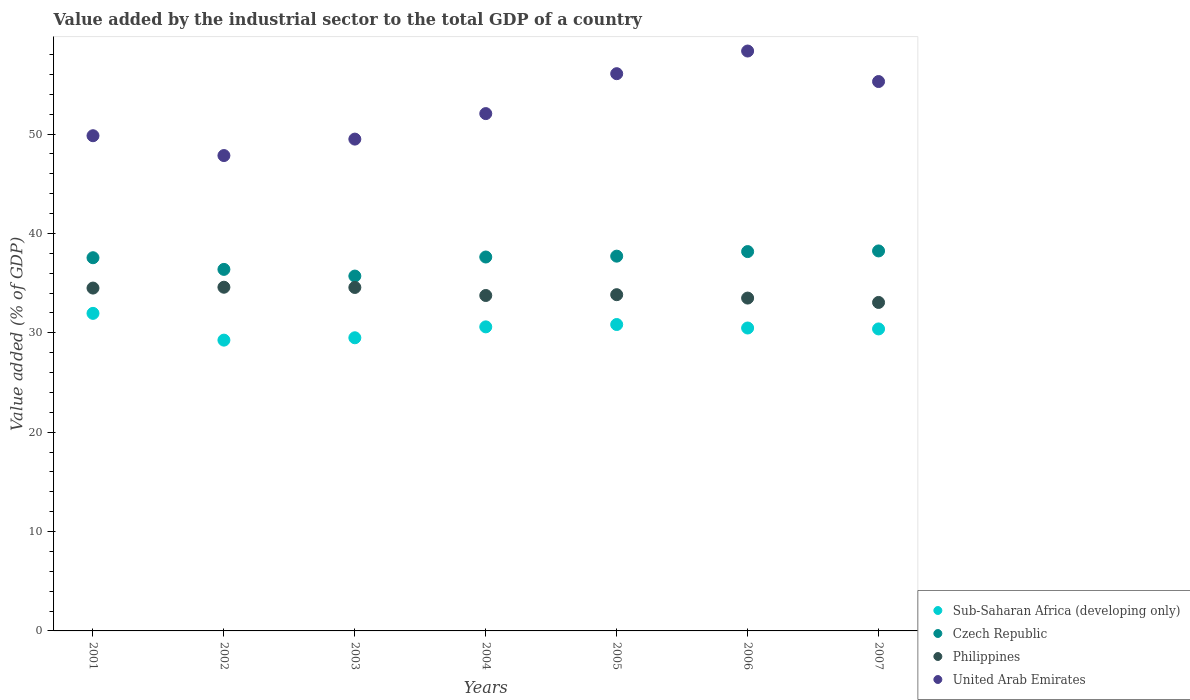How many different coloured dotlines are there?
Offer a very short reply. 4. Is the number of dotlines equal to the number of legend labels?
Offer a terse response. Yes. What is the value added by the industrial sector to the total GDP in Philippines in 2007?
Provide a short and direct response. 33.05. Across all years, what is the maximum value added by the industrial sector to the total GDP in Sub-Saharan Africa (developing only)?
Keep it short and to the point. 31.95. Across all years, what is the minimum value added by the industrial sector to the total GDP in United Arab Emirates?
Your answer should be compact. 47.83. In which year was the value added by the industrial sector to the total GDP in United Arab Emirates maximum?
Provide a short and direct response. 2006. In which year was the value added by the industrial sector to the total GDP in Sub-Saharan Africa (developing only) minimum?
Offer a very short reply. 2002. What is the total value added by the industrial sector to the total GDP in Sub-Saharan Africa (developing only) in the graph?
Make the answer very short. 213.01. What is the difference between the value added by the industrial sector to the total GDP in Sub-Saharan Africa (developing only) in 2002 and that in 2004?
Provide a short and direct response. -1.34. What is the difference between the value added by the industrial sector to the total GDP in Philippines in 2003 and the value added by the industrial sector to the total GDP in Czech Republic in 2001?
Offer a very short reply. -2.99. What is the average value added by the industrial sector to the total GDP in United Arab Emirates per year?
Offer a very short reply. 52.7. In the year 2001, what is the difference between the value added by the industrial sector to the total GDP in United Arab Emirates and value added by the industrial sector to the total GDP in Philippines?
Provide a short and direct response. 15.33. In how many years, is the value added by the industrial sector to the total GDP in United Arab Emirates greater than 50 %?
Your answer should be very brief. 4. What is the ratio of the value added by the industrial sector to the total GDP in United Arab Emirates in 2004 to that in 2005?
Give a very brief answer. 0.93. Is the difference between the value added by the industrial sector to the total GDP in United Arab Emirates in 2006 and 2007 greater than the difference between the value added by the industrial sector to the total GDP in Philippines in 2006 and 2007?
Provide a short and direct response. Yes. What is the difference between the highest and the second highest value added by the industrial sector to the total GDP in Sub-Saharan Africa (developing only)?
Your answer should be very brief. 1.12. What is the difference between the highest and the lowest value added by the industrial sector to the total GDP in Sub-Saharan Africa (developing only)?
Provide a succinct answer. 2.69. In how many years, is the value added by the industrial sector to the total GDP in United Arab Emirates greater than the average value added by the industrial sector to the total GDP in United Arab Emirates taken over all years?
Give a very brief answer. 3. Is the sum of the value added by the industrial sector to the total GDP in Sub-Saharan Africa (developing only) in 2001 and 2006 greater than the maximum value added by the industrial sector to the total GDP in Czech Republic across all years?
Provide a succinct answer. Yes. Is it the case that in every year, the sum of the value added by the industrial sector to the total GDP in Czech Republic and value added by the industrial sector to the total GDP in United Arab Emirates  is greater than the sum of value added by the industrial sector to the total GDP in Sub-Saharan Africa (developing only) and value added by the industrial sector to the total GDP in Philippines?
Provide a short and direct response. Yes. Is it the case that in every year, the sum of the value added by the industrial sector to the total GDP in United Arab Emirates and value added by the industrial sector to the total GDP in Philippines  is greater than the value added by the industrial sector to the total GDP in Czech Republic?
Your response must be concise. Yes. Is the value added by the industrial sector to the total GDP in Philippines strictly less than the value added by the industrial sector to the total GDP in Czech Republic over the years?
Your answer should be very brief. Yes. Where does the legend appear in the graph?
Provide a short and direct response. Bottom right. How are the legend labels stacked?
Make the answer very short. Vertical. What is the title of the graph?
Your response must be concise. Value added by the industrial sector to the total GDP of a country. Does "Guam" appear as one of the legend labels in the graph?
Your response must be concise. No. What is the label or title of the Y-axis?
Offer a terse response. Value added (% of GDP). What is the Value added (% of GDP) of Sub-Saharan Africa (developing only) in 2001?
Your answer should be compact. 31.95. What is the Value added (% of GDP) in Czech Republic in 2001?
Ensure brevity in your answer.  37.55. What is the Value added (% of GDP) in Philippines in 2001?
Provide a short and direct response. 34.5. What is the Value added (% of GDP) in United Arab Emirates in 2001?
Ensure brevity in your answer.  49.83. What is the Value added (% of GDP) of Sub-Saharan Africa (developing only) in 2002?
Provide a short and direct response. 29.26. What is the Value added (% of GDP) of Czech Republic in 2002?
Provide a succinct answer. 36.38. What is the Value added (% of GDP) of Philippines in 2002?
Ensure brevity in your answer.  34.58. What is the Value added (% of GDP) of United Arab Emirates in 2002?
Make the answer very short. 47.83. What is the Value added (% of GDP) of Sub-Saharan Africa (developing only) in 2003?
Provide a short and direct response. 29.5. What is the Value added (% of GDP) of Czech Republic in 2003?
Your answer should be very brief. 35.71. What is the Value added (% of GDP) in Philippines in 2003?
Offer a very short reply. 34.56. What is the Value added (% of GDP) of United Arab Emirates in 2003?
Your response must be concise. 49.49. What is the Value added (% of GDP) of Sub-Saharan Africa (developing only) in 2004?
Your answer should be compact. 30.6. What is the Value added (% of GDP) in Czech Republic in 2004?
Provide a succinct answer. 37.63. What is the Value added (% of GDP) in Philippines in 2004?
Provide a succinct answer. 33.75. What is the Value added (% of GDP) of United Arab Emirates in 2004?
Keep it short and to the point. 52.06. What is the Value added (% of GDP) of Sub-Saharan Africa (developing only) in 2005?
Offer a terse response. 30.83. What is the Value added (% of GDP) in Czech Republic in 2005?
Provide a short and direct response. 37.71. What is the Value added (% of GDP) in Philippines in 2005?
Make the answer very short. 33.83. What is the Value added (% of GDP) in United Arab Emirates in 2005?
Your answer should be very brief. 56.07. What is the Value added (% of GDP) of Sub-Saharan Africa (developing only) in 2006?
Offer a very short reply. 30.48. What is the Value added (% of GDP) in Czech Republic in 2006?
Offer a very short reply. 38.17. What is the Value added (% of GDP) of Philippines in 2006?
Your answer should be compact. 33.49. What is the Value added (% of GDP) of United Arab Emirates in 2006?
Your answer should be compact. 58.35. What is the Value added (% of GDP) in Sub-Saharan Africa (developing only) in 2007?
Offer a very short reply. 30.39. What is the Value added (% of GDP) of Czech Republic in 2007?
Offer a very short reply. 38.24. What is the Value added (% of GDP) in Philippines in 2007?
Your response must be concise. 33.05. What is the Value added (% of GDP) in United Arab Emirates in 2007?
Provide a succinct answer. 55.28. Across all years, what is the maximum Value added (% of GDP) of Sub-Saharan Africa (developing only)?
Offer a terse response. 31.95. Across all years, what is the maximum Value added (% of GDP) of Czech Republic?
Offer a very short reply. 38.24. Across all years, what is the maximum Value added (% of GDP) in Philippines?
Offer a very short reply. 34.58. Across all years, what is the maximum Value added (% of GDP) of United Arab Emirates?
Keep it short and to the point. 58.35. Across all years, what is the minimum Value added (% of GDP) in Sub-Saharan Africa (developing only)?
Provide a short and direct response. 29.26. Across all years, what is the minimum Value added (% of GDP) of Czech Republic?
Give a very brief answer. 35.71. Across all years, what is the minimum Value added (% of GDP) of Philippines?
Give a very brief answer. 33.05. Across all years, what is the minimum Value added (% of GDP) of United Arab Emirates?
Offer a very short reply. 47.83. What is the total Value added (% of GDP) in Sub-Saharan Africa (developing only) in the graph?
Your answer should be compact. 213.01. What is the total Value added (% of GDP) in Czech Republic in the graph?
Ensure brevity in your answer.  261.38. What is the total Value added (% of GDP) in Philippines in the graph?
Provide a succinct answer. 237.78. What is the total Value added (% of GDP) of United Arab Emirates in the graph?
Your answer should be very brief. 368.91. What is the difference between the Value added (% of GDP) in Sub-Saharan Africa (developing only) in 2001 and that in 2002?
Ensure brevity in your answer.  2.69. What is the difference between the Value added (% of GDP) in Czech Republic in 2001 and that in 2002?
Provide a succinct answer. 1.17. What is the difference between the Value added (% of GDP) of Philippines in 2001 and that in 2002?
Give a very brief answer. -0.08. What is the difference between the Value added (% of GDP) of United Arab Emirates in 2001 and that in 2002?
Give a very brief answer. 2. What is the difference between the Value added (% of GDP) in Sub-Saharan Africa (developing only) in 2001 and that in 2003?
Keep it short and to the point. 2.46. What is the difference between the Value added (% of GDP) in Czech Republic in 2001 and that in 2003?
Your answer should be very brief. 1.85. What is the difference between the Value added (% of GDP) in Philippines in 2001 and that in 2003?
Give a very brief answer. -0.06. What is the difference between the Value added (% of GDP) of United Arab Emirates in 2001 and that in 2003?
Make the answer very short. 0.34. What is the difference between the Value added (% of GDP) of Sub-Saharan Africa (developing only) in 2001 and that in 2004?
Keep it short and to the point. 1.36. What is the difference between the Value added (% of GDP) in Czech Republic in 2001 and that in 2004?
Offer a terse response. -0.07. What is the difference between the Value added (% of GDP) in Philippines in 2001 and that in 2004?
Offer a very short reply. 0.75. What is the difference between the Value added (% of GDP) of United Arab Emirates in 2001 and that in 2004?
Give a very brief answer. -2.23. What is the difference between the Value added (% of GDP) of Sub-Saharan Africa (developing only) in 2001 and that in 2005?
Provide a succinct answer. 1.12. What is the difference between the Value added (% of GDP) in Czech Republic in 2001 and that in 2005?
Offer a very short reply. -0.16. What is the difference between the Value added (% of GDP) of Philippines in 2001 and that in 2005?
Ensure brevity in your answer.  0.67. What is the difference between the Value added (% of GDP) in United Arab Emirates in 2001 and that in 2005?
Give a very brief answer. -6.24. What is the difference between the Value added (% of GDP) in Sub-Saharan Africa (developing only) in 2001 and that in 2006?
Ensure brevity in your answer.  1.47. What is the difference between the Value added (% of GDP) in Czech Republic in 2001 and that in 2006?
Your answer should be very brief. -0.62. What is the difference between the Value added (% of GDP) of Philippines in 2001 and that in 2006?
Provide a succinct answer. 1.01. What is the difference between the Value added (% of GDP) in United Arab Emirates in 2001 and that in 2006?
Make the answer very short. -8.52. What is the difference between the Value added (% of GDP) in Sub-Saharan Africa (developing only) in 2001 and that in 2007?
Your answer should be very brief. 1.57. What is the difference between the Value added (% of GDP) of Czech Republic in 2001 and that in 2007?
Give a very brief answer. -0.68. What is the difference between the Value added (% of GDP) of Philippines in 2001 and that in 2007?
Your answer should be very brief. 1.45. What is the difference between the Value added (% of GDP) of United Arab Emirates in 2001 and that in 2007?
Offer a terse response. -5.45. What is the difference between the Value added (% of GDP) in Sub-Saharan Africa (developing only) in 2002 and that in 2003?
Your answer should be very brief. -0.24. What is the difference between the Value added (% of GDP) of Czech Republic in 2002 and that in 2003?
Offer a terse response. 0.67. What is the difference between the Value added (% of GDP) in Philippines in 2002 and that in 2003?
Keep it short and to the point. 0.02. What is the difference between the Value added (% of GDP) of United Arab Emirates in 2002 and that in 2003?
Your answer should be very brief. -1.66. What is the difference between the Value added (% of GDP) of Sub-Saharan Africa (developing only) in 2002 and that in 2004?
Your response must be concise. -1.34. What is the difference between the Value added (% of GDP) of Czech Republic in 2002 and that in 2004?
Offer a terse response. -1.25. What is the difference between the Value added (% of GDP) of Philippines in 2002 and that in 2004?
Your answer should be very brief. 0.83. What is the difference between the Value added (% of GDP) of United Arab Emirates in 2002 and that in 2004?
Your response must be concise. -4.22. What is the difference between the Value added (% of GDP) in Sub-Saharan Africa (developing only) in 2002 and that in 2005?
Your answer should be compact. -1.57. What is the difference between the Value added (% of GDP) in Czech Republic in 2002 and that in 2005?
Ensure brevity in your answer.  -1.33. What is the difference between the Value added (% of GDP) in Philippines in 2002 and that in 2005?
Ensure brevity in your answer.  0.75. What is the difference between the Value added (% of GDP) of United Arab Emirates in 2002 and that in 2005?
Ensure brevity in your answer.  -8.24. What is the difference between the Value added (% of GDP) of Sub-Saharan Africa (developing only) in 2002 and that in 2006?
Offer a terse response. -1.22. What is the difference between the Value added (% of GDP) of Czech Republic in 2002 and that in 2006?
Offer a very short reply. -1.79. What is the difference between the Value added (% of GDP) of Philippines in 2002 and that in 2006?
Provide a succinct answer. 1.09. What is the difference between the Value added (% of GDP) in United Arab Emirates in 2002 and that in 2006?
Provide a succinct answer. -10.52. What is the difference between the Value added (% of GDP) of Sub-Saharan Africa (developing only) in 2002 and that in 2007?
Offer a terse response. -1.13. What is the difference between the Value added (% of GDP) of Czech Republic in 2002 and that in 2007?
Offer a very short reply. -1.86. What is the difference between the Value added (% of GDP) of Philippines in 2002 and that in 2007?
Your answer should be compact. 1.53. What is the difference between the Value added (% of GDP) in United Arab Emirates in 2002 and that in 2007?
Give a very brief answer. -7.45. What is the difference between the Value added (% of GDP) in Sub-Saharan Africa (developing only) in 2003 and that in 2004?
Keep it short and to the point. -1.1. What is the difference between the Value added (% of GDP) of Czech Republic in 2003 and that in 2004?
Ensure brevity in your answer.  -1.92. What is the difference between the Value added (% of GDP) in Philippines in 2003 and that in 2004?
Keep it short and to the point. 0.81. What is the difference between the Value added (% of GDP) of United Arab Emirates in 2003 and that in 2004?
Provide a succinct answer. -2.57. What is the difference between the Value added (% of GDP) of Sub-Saharan Africa (developing only) in 2003 and that in 2005?
Provide a short and direct response. -1.33. What is the difference between the Value added (% of GDP) of Czech Republic in 2003 and that in 2005?
Keep it short and to the point. -2. What is the difference between the Value added (% of GDP) of Philippines in 2003 and that in 2005?
Provide a succinct answer. 0.73. What is the difference between the Value added (% of GDP) in United Arab Emirates in 2003 and that in 2005?
Offer a very short reply. -6.58. What is the difference between the Value added (% of GDP) in Sub-Saharan Africa (developing only) in 2003 and that in 2006?
Make the answer very short. -0.98. What is the difference between the Value added (% of GDP) of Czech Republic in 2003 and that in 2006?
Your answer should be compact. -2.46. What is the difference between the Value added (% of GDP) of Philippines in 2003 and that in 2006?
Offer a terse response. 1.07. What is the difference between the Value added (% of GDP) of United Arab Emirates in 2003 and that in 2006?
Keep it short and to the point. -8.86. What is the difference between the Value added (% of GDP) of Sub-Saharan Africa (developing only) in 2003 and that in 2007?
Offer a very short reply. -0.89. What is the difference between the Value added (% of GDP) in Czech Republic in 2003 and that in 2007?
Your response must be concise. -2.53. What is the difference between the Value added (% of GDP) in Philippines in 2003 and that in 2007?
Make the answer very short. 1.51. What is the difference between the Value added (% of GDP) in United Arab Emirates in 2003 and that in 2007?
Give a very brief answer. -5.79. What is the difference between the Value added (% of GDP) in Sub-Saharan Africa (developing only) in 2004 and that in 2005?
Your answer should be very brief. -0.24. What is the difference between the Value added (% of GDP) of Czech Republic in 2004 and that in 2005?
Offer a terse response. -0.09. What is the difference between the Value added (% of GDP) in Philippines in 2004 and that in 2005?
Keep it short and to the point. -0.08. What is the difference between the Value added (% of GDP) in United Arab Emirates in 2004 and that in 2005?
Ensure brevity in your answer.  -4.02. What is the difference between the Value added (% of GDP) of Sub-Saharan Africa (developing only) in 2004 and that in 2006?
Ensure brevity in your answer.  0.11. What is the difference between the Value added (% of GDP) of Czech Republic in 2004 and that in 2006?
Your answer should be very brief. -0.55. What is the difference between the Value added (% of GDP) in Philippines in 2004 and that in 2006?
Your answer should be very brief. 0.26. What is the difference between the Value added (% of GDP) in United Arab Emirates in 2004 and that in 2006?
Your answer should be compact. -6.3. What is the difference between the Value added (% of GDP) of Sub-Saharan Africa (developing only) in 2004 and that in 2007?
Provide a succinct answer. 0.21. What is the difference between the Value added (% of GDP) of Czech Republic in 2004 and that in 2007?
Keep it short and to the point. -0.61. What is the difference between the Value added (% of GDP) in Philippines in 2004 and that in 2007?
Provide a succinct answer. 0.7. What is the difference between the Value added (% of GDP) of United Arab Emirates in 2004 and that in 2007?
Offer a terse response. -3.23. What is the difference between the Value added (% of GDP) in Sub-Saharan Africa (developing only) in 2005 and that in 2006?
Offer a terse response. 0.35. What is the difference between the Value added (% of GDP) of Czech Republic in 2005 and that in 2006?
Provide a succinct answer. -0.46. What is the difference between the Value added (% of GDP) in Philippines in 2005 and that in 2006?
Keep it short and to the point. 0.34. What is the difference between the Value added (% of GDP) of United Arab Emirates in 2005 and that in 2006?
Provide a succinct answer. -2.28. What is the difference between the Value added (% of GDP) of Sub-Saharan Africa (developing only) in 2005 and that in 2007?
Provide a short and direct response. 0.44. What is the difference between the Value added (% of GDP) in Czech Republic in 2005 and that in 2007?
Your response must be concise. -0.53. What is the difference between the Value added (% of GDP) of Philippines in 2005 and that in 2007?
Your answer should be compact. 0.78. What is the difference between the Value added (% of GDP) in United Arab Emirates in 2005 and that in 2007?
Provide a short and direct response. 0.79. What is the difference between the Value added (% of GDP) in Sub-Saharan Africa (developing only) in 2006 and that in 2007?
Your answer should be very brief. 0.09. What is the difference between the Value added (% of GDP) of Czech Republic in 2006 and that in 2007?
Keep it short and to the point. -0.07. What is the difference between the Value added (% of GDP) in Philippines in 2006 and that in 2007?
Provide a succinct answer. 0.44. What is the difference between the Value added (% of GDP) in United Arab Emirates in 2006 and that in 2007?
Give a very brief answer. 3.07. What is the difference between the Value added (% of GDP) in Sub-Saharan Africa (developing only) in 2001 and the Value added (% of GDP) in Czech Republic in 2002?
Offer a very short reply. -4.43. What is the difference between the Value added (% of GDP) in Sub-Saharan Africa (developing only) in 2001 and the Value added (% of GDP) in Philippines in 2002?
Provide a short and direct response. -2.63. What is the difference between the Value added (% of GDP) of Sub-Saharan Africa (developing only) in 2001 and the Value added (% of GDP) of United Arab Emirates in 2002?
Your answer should be very brief. -15.88. What is the difference between the Value added (% of GDP) of Czech Republic in 2001 and the Value added (% of GDP) of Philippines in 2002?
Keep it short and to the point. 2.97. What is the difference between the Value added (% of GDP) in Czech Republic in 2001 and the Value added (% of GDP) in United Arab Emirates in 2002?
Offer a terse response. -10.28. What is the difference between the Value added (% of GDP) of Philippines in 2001 and the Value added (% of GDP) of United Arab Emirates in 2002?
Your answer should be very brief. -13.33. What is the difference between the Value added (% of GDP) of Sub-Saharan Africa (developing only) in 2001 and the Value added (% of GDP) of Czech Republic in 2003?
Give a very brief answer. -3.75. What is the difference between the Value added (% of GDP) in Sub-Saharan Africa (developing only) in 2001 and the Value added (% of GDP) in Philippines in 2003?
Your response must be concise. -2.61. What is the difference between the Value added (% of GDP) in Sub-Saharan Africa (developing only) in 2001 and the Value added (% of GDP) in United Arab Emirates in 2003?
Keep it short and to the point. -17.53. What is the difference between the Value added (% of GDP) of Czech Republic in 2001 and the Value added (% of GDP) of Philippines in 2003?
Keep it short and to the point. 2.99. What is the difference between the Value added (% of GDP) in Czech Republic in 2001 and the Value added (% of GDP) in United Arab Emirates in 2003?
Provide a succinct answer. -11.94. What is the difference between the Value added (% of GDP) in Philippines in 2001 and the Value added (% of GDP) in United Arab Emirates in 2003?
Keep it short and to the point. -14.99. What is the difference between the Value added (% of GDP) of Sub-Saharan Africa (developing only) in 2001 and the Value added (% of GDP) of Czech Republic in 2004?
Provide a short and direct response. -5.67. What is the difference between the Value added (% of GDP) in Sub-Saharan Africa (developing only) in 2001 and the Value added (% of GDP) in Philippines in 2004?
Provide a short and direct response. -1.8. What is the difference between the Value added (% of GDP) of Sub-Saharan Africa (developing only) in 2001 and the Value added (% of GDP) of United Arab Emirates in 2004?
Offer a very short reply. -20.1. What is the difference between the Value added (% of GDP) in Czech Republic in 2001 and the Value added (% of GDP) in Philippines in 2004?
Your answer should be very brief. 3.8. What is the difference between the Value added (% of GDP) of Czech Republic in 2001 and the Value added (% of GDP) of United Arab Emirates in 2004?
Offer a terse response. -14.5. What is the difference between the Value added (% of GDP) in Philippines in 2001 and the Value added (% of GDP) in United Arab Emirates in 2004?
Ensure brevity in your answer.  -17.56. What is the difference between the Value added (% of GDP) of Sub-Saharan Africa (developing only) in 2001 and the Value added (% of GDP) of Czech Republic in 2005?
Your answer should be compact. -5.76. What is the difference between the Value added (% of GDP) of Sub-Saharan Africa (developing only) in 2001 and the Value added (% of GDP) of Philippines in 2005?
Provide a succinct answer. -1.88. What is the difference between the Value added (% of GDP) of Sub-Saharan Africa (developing only) in 2001 and the Value added (% of GDP) of United Arab Emirates in 2005?
Offer a terse response. -24.12. What is the difference between the Value added (% of GDP) in Czech Republic in 2001 and the Value added (% of GDP) in Philippines in 2005?
Give a very brief answer. 3.72. What is the difference between the Value added (% of GDP) in Czech Republic in 2001 and the Value added (% of GDP) in United Arab Emirates in 2005?
Give a very brief answer. -18.52. What is the difference between the Value added (% of GDP) of Philippines in 2001 and the Value added (% of GDP) of United Arab Emirates in 2005?
Keep it short and to the point. -21.57. What is the difference between the Value added (% of GDP) in Sub-Saharan Africa (developing only) in 2001 and the Value added (% of GDP) in Czech Republic in 2006?
Your response must be concise. -6.22. What is the difference between the Value added (% of GDP) of Sub-Saharan Africa (developing only) in 2001 and the Value added (% of GDP) of Philippines in 2006?
Provide a succinct answer. -1.54. What is the difference between the Value added (% of GDP) of Sub-Saharan Africa (developing only) in 2001 and the Value added (% of GDP) of United Arab Emirates in 2006?
Offer a terse response. -26.4. What is the difference between the Value added (% of GDP) in Czech Republic in 2001 and the Value added (% of GDP) in Philippines in 2006?
Ensure brevity in your answer.  4.06. What is the difference between the Value added (% of GDP) of Czech Republic in 2001 and the Value added (% of GDP) of United Arab Emirates in 2006?
Provide a short and direct response. -20.8. What is the difference between the Value added (% of GDP) of Philippines in 2001 and the Value added (% of GDP) of United Arab Emirates in 2006?
Keep it short and to the point. -23.85. What is the difference between the Value added (% of GDP) in Sub-Saharan Africa (developing only) in 2001 and the Value added (% of GDP) in Czech Republic in 2007?
Your answer should be compact. -6.28. What is the difference between the Value added (% of GDP) in Sub-Saharan Africa (developing only) in 2001 and the Value added (% of GDP) in Philippines in 2007?
Your response must be concise. -1.1. What is the difference between the Value added (% of GDP) of Sub-Saharan Africa (developing only) in 2001 and the Value added (% of GDP) of United Arab Emirates in 2007?
Provide a succinct answer. -23.33. What is the difference between the Value added (% of GDP) of Czech Republic in 2001 and the Value added (% of GDP) of Philippines in 2007?
Keep it short and to the point. 4.5. What is the difference between the Value added (% of GDP) in Czech Republic in 2001 and the Value added (% of GDP) in United Arab Emirates in 2007?
Your response must be concise. -17.73. What is the difference between the Value added (% of GDP) in Philippines in 2001 and the Value added (% of GDP) in United Arab Emirates in 2007?
Make the answer very short. -20.78. What is the difference between the Value added (% of GDP) in Sub-Saharan Africa (developing only) in 2002 and the Value added (% of GDP) in Czech Republic in 2003?
Your answer should be compact. -6.45. What is the difference between the Value added (% of GDP) of Sub-Saharan Africa (developing only) in 2002 and the Value added (% of GDP) of Philippines in 2003?
Make the answer very short. -5.3. What is the difference between the Value added (% of GDP) in Sub-Saharan Africa (developing only) in 2002 and the Value added (% of GDP) in United Arab Emirates in 2003?
Your answer should be compact. -20.23. What is the difference between the Value added (% of GDP) of Czech Republic in 2002 and the Value added (% of GDP) of Philippines in 2003?
Offer a terse response. 1.82. What is the difference between the Value added (% of GDP) of Czech Republic in 2002 and the Value added (% of GDP) of United Arab Emirates in 2003?
Ensure brevity in your answer.  -13.11. What is the difference between the Value added (% of GDP) in Philippines in 2002 and the Value added (% of GDP) in United Arab Emirates in 2003?
Ensure brevity in your answer.  -14.91. What is the difference between the Value added (% of GDP) of Sub-Saharan Africa (developing only) in 2002 and the Value added (% of GDP) of Czech Republic in 2004?
Your answer should be very brief. -8.36. What is the difference between the Value added (% of GDP) of Sub-Saharan Africa (developing only) in 2002 and the Value added (% of GDP) of Philippines in 2004?
Provide a short and direct response. -4.49. What is the difference between the Value added (% of GDP) in Sub-Saharan Africa (developing only) in 2002 and the Value added (% of GDP) in United Arab Emirates in 2004?
Your answer should be compact. -22.8. What is the difference between the Value added (% of GDP) of Czech Republic in 2002 and the Value added (% of GDP) of Philippines in 2004?
Your answer should be compact. 2.63. What is the difference between the Value added (% of GDP) in Czech Republic in 2002 and the Value added (% of GDP) in United Arab Emirates in 2004?
Provide a short and direct response. -15.68. What is the difference between the Value added (% of GDP) of Philippines in 2002 and the Value added (% of GDP) of United Arab Emirates in 2004?
Offer a terse response. -17.47. What is the difference between the Value added (% of GDP) in Sub-Saharan Africa (developing only) in 2002 and the Value added (% of GDP) in Czech Republic in 2005?
Your answer should be compact. -8.45. What is the difference between the Value added (% of GDP) of Sub-Saharan Africa (developing only) in 2002 and the Value added (% of GDP) of Philippines in 2005?
Provide a succinct answer. -4.57. What is the difference between the Value added (% of GDP) of Sub-Saharan Africa (developing only) in 2002 and the Value added (% of GDP) of United Arab Emirates in 2005?
Provide a succinct answer. -26.81. What is the difference between the Value added (% of GDP) of Czech Republic in 2002 and the Value added (% of GDP) of Philippines in 2005?
Your response must be concise. 2.55. What is the difference between the Value added (% of GDP) of Czech Republic in 2002 and the Value added (% of GDP) of United Arab Emirates in 2005?
Give a very brief answer. -19.69. What is the difference between the Value added (% of GDP) of Philippines in 2002 and the Value added (% of GDP) of United Arab Emirates in 2005?
Make the answer very short. -21.49. What is the difference between the Value added (% of GDP) in Sub-Saharan Africa (developing only) in 2002 and the Value added (% of GDP) in Czech Republic in 2006?
Make the answer very short. -8.91. What is the difference between the Value added (% of GDP) of Sub-Saharan Africa (developing only) in 2002 and the Value added (% of GDP) of Philippines in 2006?
Keep it short and to the point. -4.23. What is the difference between the Value added (% of GDP) in Sub-Saharan Africa (developing only) in 2002 and the Value added (% of GDP) in United Arab Emirates in 2006?
Your answer should be very brief. -29.09. What is the difference between the Value added (% of GDP) in Czech Republic in 2002 and the Value added (% of GDP) in Philippines in 2006?
Ensure brevity in your answer.  2.89. What is the difference between the Value added (% of GDP) in Czech Republic in 2002 and the Value added (% of GDP) in United Arab Emirates in 2006?
Your answer should be compact. -21.97. What is the difference between the Value added (% of GDP) in Philippines in 2002 and the Value added (% of GDP) in United Arab Emirates in 2006?
Offer a very short reply. -23.77. What is the difference between the Value added (% of GDP) in Sub-Saharan Africa (developing only) in 2002 and the Value added (% of GDP) in Czech Republic in 2007?
Provide a succinct answer. -8.98. What is the difference between the Value added (% of GDP) in Sub-Saharan Africa (developing only) in 2002 and the Value added (% of GDP) in Philippines in 2007?
Your answer should be very brief. -3.79. What is the difference between the Value added (% of GDP) in Sub-Saharan Africa (developing only) in 2002 and the Value added (% of GDP) in United Arab Emirates in 2007?
Make the answer very short. -26.02. What is the difference between the Value added (% of GDP) in Czech Republic in 2002 and the Value added (% of GDP) in Philippines in 2007?
Your answer should be compact. 3.33. What is the difference between the Value added (% of GDP) of Czech Republic in 2002 and the Value added (% of GDP) of United Arab Emirates in 2007?
Offer a very short reply. -18.9. What is the difference between the Value added (% of GDP) of Philippines in 2002 and the Value added (% of GDP) of United Arab Emirates in 2007?
Your answer should be very brief. -20.7. What is the difference between the Value added (% of GDP) in Sub-Saharan Africa (developing only) in 2003 and the Value added (% of GDP) in Czech Republic in 2004?
Make the answer very short. -8.13. What is the difference between the Value added (% of GDP) in Sub-Saharan Africa (developing only) in 2003 and the Value added (% of GDP) in Philippines in 2004?
Ensure brevity in your answer.  -4.25. What is the difference between the Value added (% of GDP) in Sub-Saharan Africa (developing only) in 2003 and the Value added (% of GDP) in United Arab Emirates in 2004?
Offer a terse response. -22.56. What is the difference between the Value added (% of GDP) of Czech Republic in 2003 and the Value added (% of GDP) of Philippines in 2004?
Ensure brevity in your answer.  1.95. What is the difference between the Value added (% of GDP) in Czech Republic in 2003 and the Value added (% of GDP) in United Arab Emirates in 2004?
Offer a very short reply. -16.35. What is the difference between the Value added (% of GDP) in Philippines in 2003 and the Value added (% of GDP) in United Arab Emirates in 2004?
Give a very brief answer. -17.49. What is the difference between the Value added (% of GDP) in Sub-Saharan Africa (developing only) in 2003 and the Value added (% of GDP) in Czech Republic in 2005?
Your answer should be compact. -8.21. What is the difference between the Value added (% of GDP) of Sub-Saharan Africa (developing only) in 2003 and the Value added (% of GDP) of Philippines in 2005?
Make the answer very short. -4.34. What is the difference between the Value added (% of GDP) in Sub-Saharan Africa (developing only) in 2003 and the Value added (% of GDP) in United Arab Emirates in 2005?
Offer a very short reply. -26.57. What is the difference between the Value added (% of GDP) of Czech Republic in 2003 and the Value added (% of GDP) of Philippines in 2005?
Provide a short and direct response. 1.87. What is the difference between the Value added (% of GDP) of Czech Republic in 2003 and the Value added (% of GDP) of United Arab Emirates in 2005?
Your response must be concise. -20.36. What is the difference between the Value added (% of GDP) of Philippines in 2003 and the Value added (% of GDP) of United Arab Emirates in 2005?
Your answer should be very brief. -21.51. What is the difference between the Value added (% of GDP) in Sub-Saharan Africa (developing only) in 2003 and the Value added (% of GDP) in Czech Republic in 2006?
Ensure brevity in your answer.  -8.67. What is the difference between the Value added (% of GDP) of Sub-Saharan Africa (developing only) in 2003 and the Value added (% of GDP) of Philippines in 2006?
Provide a succinct answer. -3.99. What is the difference between the Value added (% of GDP) in Sub-Saharan Africa (developing only) in 2003 and the Value added (% of GDP) in United Arab Emirates in 2006?
Provide a succinct answer. -28.85. What is the difference between the Value added (% of GDP) in Czech Republic in 2003 and the Value added (% of GDP) in Philippines in 2006?
Keep it short and to the point. 2.21. What is the difference between the Value added (% of GDP) of Czech Republic in 2003 and the Value added (% of GDP) of United Arab Emirates in 2006?
Give a very brief answer. -22.64. What is the difference between the Value added (% of GDP) in Philippines in 2003 and the Value added (% of GDP) in United Arab Emirates in 2006?
Your answer should be very brief. -23.79. What is the difference between the Value added (% of GDP) in Sub-Saharan Africa (developing only) in 2003 and the Value added (% of GDP) in Czech Republic in 2007?
Ensure brevity in your answer.  -8.74. What is the difference between the Value added (% of GDP) in Sub-Saharan Africa (developing only) in 2003 and the Value added (% of GDP) in Philippines in 2007?
Give a very brief answer. -3.55. What is the difference between the Value added (% of GDP) of Sub-Saharan Africa (developing only) in 2003 and the Value added (% of GDP) of United Arab Emirates in 2007?
Keep it short and to the point. -25.78. What is the difference between the Value added (% of GDP) in Czech Republic in 2003 and the Value added (% of GDP) in Philippines in 2007?
Offer a very short reply. 2.65. What is the difference between the Value added (% of GDP) of Czech Republic in 2003 and the Value added (% of GDP) of United Arab Emirates in 2007?
Make the answer very short. -19.57. What is the difference between the Value added (% of GDP) in Philippines in 2003 and the Value added (% of GDP) in United Arab Emirates in 2007?
Give a very brief answer. -20.72. What is the difference between the Value added (% of GDP) of Sub-Saharan Africa (developing only) in 2004 and the Value added (% of GDP) of Czech Republic in 2005?
Your answer should be very brief. -7.12. What is the difference between the Value added (% of GDP) of Sub-Saharan Africa (developing only) in 2004 and the Value added (% of GDP) of Philippines in 2005?
Keep it short and to the point. -3.24. What is the difference between the Value added (% of GDP) of Sub-Saharan Africa (developing only) in 2004 and the Value added (% of GDP) of United Arab Emirates in 2005?
Provide a succinct answer. -25.48. What is the difference between the Value added (% of GDP) of Czech Republic in 2004 and the Value added (% of GDP) of Philippines in 2005?
Your response must be concise. 3.79. What is the difference between the Value added (% of GDP) of Czech Republic in 2004 and the Value added (% of GDP) of United Arab Emirates in 2005?
Your answer should be very brief. -18.45. What is the difference between the Value added (% of GDP) in Philippines in 2004 and the Value added (% of GDP) in United Arab Emirates in 2005?
Keep it short and to the point. -22.32. What is the difference between the Value added (% of GDP) of Sub-Saharan Africa (developing only) in 2004 and the Value added (% of GDP) of Czech Republic in 2006?
Your answer should be very brief. -7.58. What is the difference between the Value added (% of GDP) of Sub-Saharan Africa (developing only) in 2004 and the Value added (% of GDP) of Philippines in 2006?
Your answer should be compact. -2.9. What is the difference between the Value added (% of GDP) in Sub-Saharan Africa (developing only) in 2004 and the Value added (% of GDP) in United Arab Emirates in 2006?
Make the answer very short. -27.76. What is the difference between the Value added (% of GDP) of Czech Republic in 2004 and the Value added (% of GDP) of Philippines in 2006?
Your answer should be very brief. 4.13. What is the difference between the Value added (% of GDP) of Czech Republic in 2004 and the Value added (% of GDP) of United Arab Emirates in 2006?
Offer a very short reply. -20.73. What is the difference between the Value added (% of GDP) in Philippines in 2004 and the Value added (% of GDP) in United Arab Emirates in 2006?
Ensure brevity in your answer.  -24.6. What is the difference between the Value added (% of GDP) in Sub-Saharan Africa (developing only) in 2004 and the Value added (% of GDP) in Czech Republic in 2007?
Your response must be concise. -7.64. What is the difference between the Value added (% of GDP) of Sub-Saharan Africa (developing only) in 2004 and the Value added (% of GDP) of Philippines in 2007?
Provide a succinct answer. -2.46. What is the difference between the Value added (% of GDP) in Sub-Saharan Africa (developing only) in 2004 and the Value added (% of GDP) in United Arab Emirates in 2007?
Ensure brevity in your answer.  -24.69. What is the difference between the Value added (% of GDP) of Czech Republic in 2004 and the Value added (% of GDP) of Philippines in 2007?
Offer a terse response. 4.57. What is the difference between the Value added (% of GDP) in Czech Republic in 2004 and the Value added (% of GDP) in United Arab Emirates in 2007?
Your answer should be very brief. -17.66. What is the difference between the Value added (% of GDP) in Philippines in 2004 and the Value added (% of GDP) in United Arab Emirates in 2007?
Keep it short and to the point. -21.53. What is the difference between the Value added (% of GDP) of Sub-Saharan Africa (developing only) in 2005 and the Value added (% of GDP) of Czech Republic in 2006?
Make the answer very short. -7.34. What is the difference between the Value added (% of GDP) of Sub-Saharan Africa (developing only) in 2005 and the Value added (% of GDP) of Philippines in 2006?
Provide a succinct answer. -2.66. What is the difference between the Value added (% of GDP) in Sub-Saharan Africa (developing only) in 2005 and the Value added (% of GDP) in United Arab Emirates in 2006?
Offer a terse response. -27.52. What is the difference between the Value added (% of GDP) of Czech Republic in 2005 and the Value added (% of GDP) of Philippines in 2006?
Provide a succinct answer. 4.22. What is the difference between the Value added (% of GDP) of Czech Republic in 2005 and the Value added (% of GDP) of United Arab Emirates in 2006?
Ensure brevity in your answer.  -20.64. What is the difference between the Value added (% of GDP) of Philippines in 2005 and the Value added (% of GDP) of United Arab Emirates in 2006?
Make the answer very short. -24.52. What is the difference between the Value added (% of GDP) of Sub-Saharan Africa (developing only) in 2005 and the Value added (% of GDP) of Czech Republic in 2007?
Make the answer very short. -7.4. What is the difference between the Value added (% of GDP) of Sub-Saharan Africa (developing only) in 2005 and the Value added (% of GDP) of Philippines in 2007?
Your response must be concise. -2.22. What is the difference between the Value added (% of GDP) in Sub-Saharan Africa (developing only) in 2005 and the Value added (% of GDP) in United Arab Emirates in 2007?
Make the answer very short. -24.45. What is the difference between the Value added (% of GDP) of Czech Republic in 2005 and the Value added (% of GDP) of Philippines in 2007?
Provide a succinct answer. 4.66. What is the difference between the Value added (% of GDP) of Czech Republic in 2005 and the Value added (% of GDP) of United Arab Emirates in 2007?
Offer a very short reply. -17.57. What is the difference between the Value added (% of GDP) of Philippines in 2005 and the Value added (% of GDP) of United Arab Emirates in 2007?
Your answer should be compact. -21.45. What is the difference between the Value added (% of GDP) in Sub-Saharan Africa (developing only) in 2006 and the Value added (% of GDP) in Czech Republic in 2007?
Offer a terse response. -7.76. What is the difference between the Value added (% of GDP) in Sub-Saharan Africa (developing only) in 2006 and the Value added (% of GDP) in Philippines in 2007?
Provide a short and direct response. -2.57. What is the difference between the Value added (% of GDP) of Sub-Saharan Africa (developing only) in 2006 and the Value added (% of GDP) of United Arab Emirates in 2007?
Ensure brevity in your answer.  -24.8. What is the difference between the Value added (% of GDP) of Czech Republic in 2006 and the Value added (% of GDP) of Philippines in 2007?
Provide a succinct answer. 5.12. What is the difference between the Value added (% of GDP) of Czech Republic in 2006 and the Value added (% of GDP) of United Arab Emirates in 2007?
Make the answer very short. -17.11. What is the difference between the Value added (% of GDP) in Philippines in 2006 and the Value added (% of GDP) in United Arab Emirates in 2007?
Your answer should be very brief. -21.79. What is the average Value added (% of GDP) in Sub-Saharan Africa (developing only) per year?
Your answer should be compact. 30.43. What is the average Value added (% of GDP) in Czech Republic per year?
Your answer should be very brief. 37.34. What is the average Value added (% of GDP) in Philippines per year?
Give a very brief answer. 33.97. What is the average Value added (% of GDP) in United Arab Emirates per year?
Make the answer very short. 52.7. In the year 2001, what is the difference between the Value added (% of GDP) in Sub-Saharan Africa (developing only) and Value added (% of GDP) in Czech Republic?
Make the answer very short. -5.6. In the year 2001, what is the difference between the Value added (% of GDP) in Sub-Saharan Africa (developing only) and Value added (% of GDP) in Philippines?
Offer a very short reply. -2.55. In the year 2001, what is the difference between the Value added (% of GDP) of Sub-Saharan Africa (developing only) and Value added (% of GDP) of United Arab Emirates?
Make the answer very short. -17.88. In the year 2001, what is the difference between the Value added (% of GDP) in Czech Republic and Value added (% of GDP) in Philippines?
Your answer should be compact. 3.05. In the year 2001, what is the difference between the Value added (% of GDP) of Czech Republic and Value added (% of GDP) of United Arab Emirates?
Give a very brief answer. -12.28. In the year 2001, what is the difference between the Value added (% of GDP) of Philippines and Value added (% of GDP) of United Arab Emirates?
Make the answer very short. -15.33. In the year 2002, what is the difference between the Value added (% of GDP) in Sub-Saharan Africa (developing only) and Value added (% of GDP) in Czech Republic?
Provide a short and direct response. -7.12. In the year 2002, what is the difference between the Value added (% of GDP) in Sub-Saharan Africa (developing only) and Value added (% of GDP) in Philippines?
Your answer should be very brief. -5.32. In the year 2002, what is the difference between the Value added (% of GDP) of Sub-Saharan Africa (developing only) and Value added (% of GDP) of United Arab Emirates?
Offer a terse response. -18.57. In the year 2002, what is the difference between the Value added (% of GDP) in Czech Republic and Value added (% of GDP) in Philippines?
Offer a terse response. 1.8. In the year 2002, what is the difference between the Value added (% of GDP) of Czech Republic and Value added (% of GDP) of United Arab Emirates?
Provide a succinct answer. -11.45. In the year 2002, what is the difference between the Value added (% of GDP) in Philippines and Value added (% of GDP) in United Arab Emirates?
Your response must be concise. -13.25. In the year 2003, what is the difference between the Value added (% of GDP) in Sub-Saharan Africa (developing only) and Value added (% of GDP) in Czech Republic?
Keep it short and to the point. -6.21. In the year 2003, what is the difference between the Value added (% of GDP) of Sub-Saharan Africa (developing only) and Value added (% of GDP) of Philippines?
Offer a terse response. -5.06. In the year 2003, what is the difference between the Value added (% of GDP) in Sub-Saharan Africa (developing only) and Value added (% of GDP) in United Arab Emirates?
Provide a succinct answer. -19.99. In the year 2003, what is the difference between the Value added (% of GDP) in Czech Republic and Value added (% of GDP) in Philippines?
Provide a succinct answer. 1.15. In the year 2003, what is the difference between the Value added (% of GDP) of Czech Republic and Value added (% of GDP) of United Arab Emirates?
Your answer should be compact. -13.78. In the year 2003, what is the difference between the Value added (% of GDP) of Philippines and Value added (% of GDP) of United Arab Emirates?
Keep it short and to the point. -14.93. In the year 2004, what is the difference between the Value added (% of GDP) in Sub-Saharan Africa (developing only) and Value added (% of GDP) in Czech Republic?
Provide a succinct answer. -7.03. In the year 2004, what is the difference between the Value added (% of GDP) of Sub-Saharan Africa (developing only) and Value added (% of GDP) of Philippines?
Provide a succinct answer. -3.16. In the year 2004, what is the difference between the Value added (% of GDP) in Sub-Saharan Africa (developing only) and Value added (% of GDP) in United Arab Emirates?
Provide a succinct answer. -21.46. In the year 2004, what is the difference between the Value added (% of GDP) in Czech Republic and Value added (% of GDP) in Philippines?
Make the answer very short. 3.87. In the year 2004, what is the difference between the Value added (% of GDP) of Czech Republic and Value added (% of GDP) of United Arab Emirates?
Make the answer very short. -14.43. In the year 2004, what is the difference between the Value added (% of GDP) in Philippines and Value added (% of GDP) in United Arab Emirates?
Provide a short and direct response. -18.3. In the year 2005, what is the difference between the Value added (% of GDP) of Sub-Saharan Africa (developing only) and Value added (% of GDP) of Czech Republic?
Your answer should be very brief. -6.88. In the year 2005, what is the difference between the Value added (% of GDP) of Sub-Saharan Africa (developing only) and Value added (% of GDP) of Philippines?
Provide a short and direct response. -3. In the year 2005, what is the difference between the Value added (% of GDP) in Sub-Saharan Africa (developing only) and Value added (% of GDP) in United Arab Emirates?
Provide a succinct answer. -25.24. In the year 2005, what is the difference between the Value added (% of GDP) of Czech Republic and Value added (% of GDP) of Philippines?
Provide a succinct answer. 3.88. In the year 2005, what is the difference between the Value added (% of GDP) of Czech Republic and Value added (% of GDP) of United Arab Emirates?
Your response must be concise. -18.36. In the year 2005, what is the difference between the Value added (% of GDP) in Philippines and Value added (% of GDP) in United Arab Emirates?
Your answer should be very brief. -22.24. In the year 2006, what is the difference between the Value added (% of GDP) of Sub-Saharan Africa (developing only) and Value added (% of GDP) of Czech Republic?
Give a very brief answer. -7.69. In the year 2006, what is the difference between the Value added (% of GDP) of Sub-Saharan Africa (developing only) and Value added (% of GDP) of Philippines?
Offer a terse response. -3.01. In the year 2006, what is the difference between the Value added (% of GDP) of Sub-Saharan Africa (developing only) and Value added (% of GDP) of United Arab Emirates?
Provide a succinct answer. -27.87. In the year 2006, what is the difference between the Value added (% of GDP) of Czech Republic and Value added (% of GDP) of Philippines?
Make the answer very short. 4.68. In the year 2006, what is the difference between the Value added (% of GDP) of Czech Republic and Value added (% of GDP) of United Arab Emirates?
Ensure brevity in your answer.  -20.18. In the year 2006, what is the difference between the Value added (% of GDP) of Philippines and Value added (% of GDP) of United Arab Emirates?
Offer a terse response. -24.86. In the year 2007, what is the difference between the Value added (% of GDP) in Sub-Saharan Africa (developing only) and Value added (% of GDP) in Czech Republic?
Your response must be concise. -7.85. In the year 2007, what is the difference between the Value added (% of GDP) in Sub-Saharan Africa (developing only) and Value added (% of GDP) in Philippines?
Keep it short and to the point. -2.67. In the year 2007, what is the difference between the Value added (% of GDP) of Sub-Saharan Africa (developing only) and Value added (% of GDP) of United Arab Emirates?
Give a very brief answer. -24.89. In the year 2007, what is the difference between the Value added (% of GDP) in Czech Republic and Value added (% of GDP) in Philippines?
Your answer should be very brief. 5.18. In the year 2007, what is the difference between the Value added (% of GDP) in Czech Republic and Value added (% of GDP) in United Arab Emirates?
Your answer should be very brief. -17.04. In the year 2007, what is the difference between the Value added (% of GDP) of Philippines and Value added (% of GDP) of United Arab Emirates?
Make the answer very short. -22.23. What is the ratio of the Value added (% of GDP) in Sub-Saharan Africa (developing only) in 2001 to that in 2002?
Keep it short and to the point. 1.09. What is the ratio of the Value added (% of GDP) of Czech Republic in 2001 to that in 2002?
Keep it short and to the point. 1.03. What is the ratio of the Value added (% of GDP) of United Arab Emirates in 2001 to that in 2002?
Make the answer very short. 1.04. What is the ratio of the Value added (% of GDP) in Sub-Saharan Africa (developing only) in 2001 to that in 2003?
Your response must be concise. 1.08. What is the ratio of the Value added (% of GDP) in Czech Republic in 2001 to that in 2003?
Your response must be concise. 1.05. What is the ratio of the Value added (% of GDP) in Sub-Saharan Africa (developing only) in 2001 to that in 2004?
Your answer should be very brief. 1.04. What is the ratio of the Value added (% of GDP) in Philippines in 2001 to that in 2004?
Ensure brevity in your answer.  1.02. What is the ratio of the Value added (% of GDP) in United Arab Emirates in 2001 to that in 2004?
Give a very brief answer. 0.96. What is the ratio of the Value added (% of GDP) in Sub-Saharan Africa (developing only) in 2001 to that in 2005?
Offer a very short reply. 1.04. What is the ratio of the Value added (% of GDP) of Czech Republic in 2001 to that in 2005?
Ensure brevity in your answer.  1. What is the ratio of the Value added (% of GDP) of Philippines in 2001 to that in 2005?
Provide a succinct answer. 1.02. What is the ratio of the Value added (% of GDP) in United Arab Emirates in 2001 to that in 2005?
Provide a succinct answer. 0.89. What is the ratio of the Value added (% of GDP) of Sub-Saharan Africa (developing only) in 2001 to that in 2006?
Your answer should be very brief. 1.05. What is the ratio of the Value added (% of GDP) in Czech Republic in 2001 to that in 2006?
Provide a short and direct response. 0.98. What is the ratio of the Value added (% of GDP) of Philippines in 2001 to that in 2006?
Keep it short and to the point. 1.03. What is the ratio of the Value added (% of GDP) in United Arab Emirates in 2001 to that in 2006?
Offer a terse response. 0.85. What is the ratio of the Value added (% of GDP) of Sub-Saharan Africa (developing only) in 2001 to that in 2007?
Provide a short and direct response. 1.05. What is the ratio of the Value added (% of GDP) in Czech Republic in 2001 to that in 2007?
Your answer should be compact. 0.98. What is the ratio of the Value added (% of GDP) in Philippines in 2001 to that in 2007?
Provide a succinct answer. 1.04. What is the ratio of the Value added (% of GDP) in United Arab Emirates in 2001 to that in 2007?
Make the answer very short. 0.9. What is the ratio of the Value added (% of GDP) of Czech Republic in 2002 to that in 2003?
Offer a very short reply. 1.02. What is the ratio of the Value added (% of GDP) in United Arab Emirates in 2002 to that in 2003?
Your answer should be compact. 0.97. What is the ratio of the Value added (% of GDP) in Sub-Saharan Africa (developing only) in 2002 to that in 2004?
Your answer should be compact. 0.96. What is the ratio of the Value added (% of GDP) of Czech Republic in 2002 to that in 2004?
Provide a short and direct response. 0.97. What is the ratio of the Value added (% of GDP) of Philippines in 2002 to that in 2004?
Offer a terse response. 1.02. What is the ratio of the Value added (% of GDP) in United Arab Emirates in 2002 to that in 2004?
Make the answer very short. 0.92. What is the ratio of the Value added (% of GDP) of Sub-Saharan Africa (developing only) in 2002 to that in 2005?
Make the answer very short. 0.95. What is the ratio of the Value added (% of GDP) of Czech Republic in 2002 to that in 2005?
Give a very brief answer. 0.96. What is the ratio of the Value added (% of GDP) of Philippines in 2002 to that in 2005?
Your response must be concise. 1.02. What is the ratio of the Value added (% of GDP) in United Arab Emirates in 2002 to that in 2005?
Your response must be concise. 0.85. What is the ratio of the Value added (% of GDP) of Czech Republic in 2002 to that in 2006?
Give a very brief answer. 0.95. What is the ratio of the Value added (% of GDP) in Philippines in 2002 to that in 2006?
Provide a succinct answer. 1.03. What is the ratio of the Value added (% of GDP) of United Arab Emirates in 2002 to that in 2006?
Offer a very short reply. 0.82. What is the ratio of the Value added (% of GDP) of Sub-Saharan Africa (developing only) in 2002 to that in 2007?
Ensure brevity in your answer.  0.96. What is the ratio of the Value added (% of GDP) in Czech Republic in 2002 to that in 2007?
Keep it short and to the point. 0.95. What is the ratio of the Value added (% of GDP) of Philippines in 2002 to that in 2007?
Make the answer very short. 1.05. What is the ratio of the Value added (% of GDP) of United Arab Emirates in 2002 to that in 2007?
Offer a very short reply. 0.87. What is the ratio of the Value added (% of GDP) in Sub-Saharan Africa (developing only) in 2003 to that in 2004?
Offer a terse response. 0.96. What is the ratio of the Value added (% of GDP) in Czech Republic in 2003 to that in 2004?
Make the answer very short. 0.95. What is the ratio of the Value added (% of GDP) of Philippines in 2003 to that in 2004?
Give a very brief answer. 1.02. What is the ratio of the Value added (% of GDP) of United Arab Emirates in 2003 to that in 2004?
Provide a short and direct response. 0.95. What is the ratio of the Value added (% of GDP) in Sub-Saharan Africa (developing only) in 2003 to that in 2005?
Offer a very short reply. 0.96. What is the ratio of the Value added (% of GDP) in Czech Republic in 2003 to that in 2005?
Your answer should be very brief. 0.95. What is the ratio of the Value added (% of GDP) in Philippines in 2003 to that in 2005?
Give a very brief answer. 1.02. What is the ratio of the Value added (% of GDP) of United Arab Emirates in 2003 to that in 2005?
Your response must be concise. 0.88. What is the ratio of the Value added (% of GDP) in Sub-Saharan Africa (developing only) in 2003 to that in 2006?
Make the answer very short. 0.97. What is the ratio of the Value added (% of GDP) of Czech Republic in 2003 to that in 2006?
Your answer should be compact. 0.94. What is the ratio of the Value added (% of GDP) of Philippines in 2003 to that in 2006?
Your response must be concise. 1.03. What is the ratio of the Value added (% of GDP) in United Arab Emirates in 2003 to that in 2006?
Your answer should be very brief. 0.85. What is the ratio of the Value added (% of GDP) in Sub-Saharan Africa (developing only) in 2003 to that in 2007?
Offer a very short reply. 0.97. What is the ratio of the Value added (% of GDP) in Czech Republic in 2003 to that in 2007?
Provide a succinct answer. 0.93. What is the ratio of the Value added (% of GDP) of Philippines in 2003 to that in 2007?
Your response must be concise. 1.05. What is the ratio of the Value added (% of GDP) in United Arab Emirates in 2003 to that in 2007?
Provide a succinct answer. 0.9. What is the ratio of the Value added (% of GDP) of United Arab Emirates in 2004 to that in 2005?
Offer a very short reply. 0.93. What is the ratio of the Value added (% of GDP) in Czech Republic in 2004 to that in 2006?
Make the answer very short. 0.99. What is the ratio of the Value added (% of GDP) of Philippines in 2004 to that in 2006?
Offer a very short reply. 1.01. What is the ratio of the Value added (% of GDP) of United Arab Emirates in 2004 to that in 2006?
Provide a short and direct response. 0.89. What is the ratio of the Value added (% of GDP) in Sub-Saharan Africa (developing only) in 2004 to that in 2007?
Offer a terse response. 1.01. What is the ratio of the Value added (% of GDP) in Czech Republic in 2004 to that in 2007?
Your answer should be compact. 0.98. What is the ratio of the Value added (% of GDP) of Philippines in 2004 to that in 2007?
Ensure brevity in your answer.  1.02. What is the ratio of the Value added (% of GDP) in United Arab Emirates in 2004 to that in 2007?
Offer a very short reply. 0.94. What is the ratio of the Value added (% of GDP) in Sub-Saharan Africa (developing only) in 2005 to that in 2006?
Make the answer very short. 1.01. What is the ratio of the Value added (% of GDP) of Philippines in 2005 to that in 2006?
Give a very brief answer. 1.01. What is the ratio of the Value added (% of GDP) of United Arab Emirates in 2005 to that in 2006?
Offer a terse response. 0.96. What is the ratio of the Value added (% of GDP) in Sub-Saharan Africa (developing only) in 2005 to that in 2007?
Your answer should be compact. 1.01. What is the ratio of the Value added (% of GDP) of Czech Republic in 2005 to that in 2007?
Your answer should be very brief. 0.99. What is the ratio of the Value added (% of GDP) in Philippines in 2005 to that in 2007?
Keep it short and to the point. 1.02. What is the ratio of the Value added (% of GDP) of United Arab Emirates in 2005 to that in 2007?
Give a very brief answer. 1.01. What is the ratio of the Value added (% of GDP) in Sub-Saharan Africa (developing only) in 2006 to that in 2007?
Give a very brief answer. 1. What is the ratio of the Value added (% of GDP) of Czech Republic in 2006 to that in 2007?
Make the answer very short. 1. What is the ratio of the Value added (% of GDP) of Philippines in 2006 to that in 2007?
Ensure brevity in your answer.  1.01. What is the ratio of the Value added (% of GDP) of United Arab Emirates in 2006 to that in 2007?
Offer a very short reply. 1.06. What is the difference between the highest and the second highest Value added (% of GDP) of Sub-Saharan Africa (developing only)?
Your answer should be compact. 1.12. What is the difference between the highest and the second highest Value added (% of GDP) in Czech Republic?
Provide a succinct answer. 0.07. What is the difference between the highest and the second highest Value added (% of GDP) in Philippines?
Give a very brief answer. 0.02. What is the difference between the highest and the second highest Value added (% of GDP) in United Arab Emirates?
Ensure brevity in your answer.  2.28. What is the difference between the highest and the lowest Value added (% of GDP) in Sub-Saharan Africa (developing only)?
Your response must be concise. 2.69. What is the difference between the highest and the lowest Value added (% of GDP) of Czech Republic?
Keep it short and to the point. 2.53. What is the difference between the highest and the lowest Value added (% of GDP) in Philippines?
Offer a very short reply. 1.53. What is the difference between the highest and the lowest Value added (% of GDP) of United Arab Emirates?
Give a very brief answer. 10.52. 